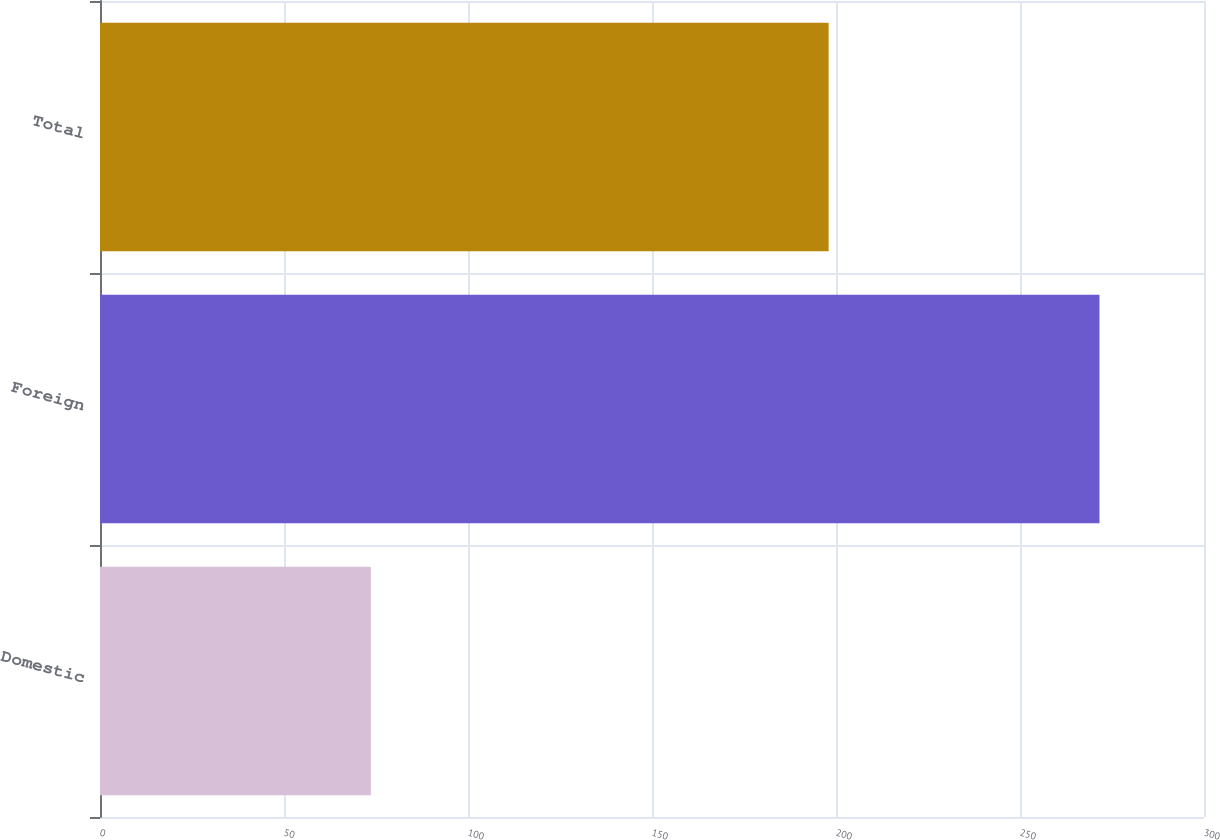Convert chart to OTSL. <chart><loc_0><loc_0><loc_500><loc_500><bar_chart><fcel>Domestic<fcel>Foreign<fcel>Total<nl><fcel>73.6<fcel>271.6<fcel>198<nl></chart> 